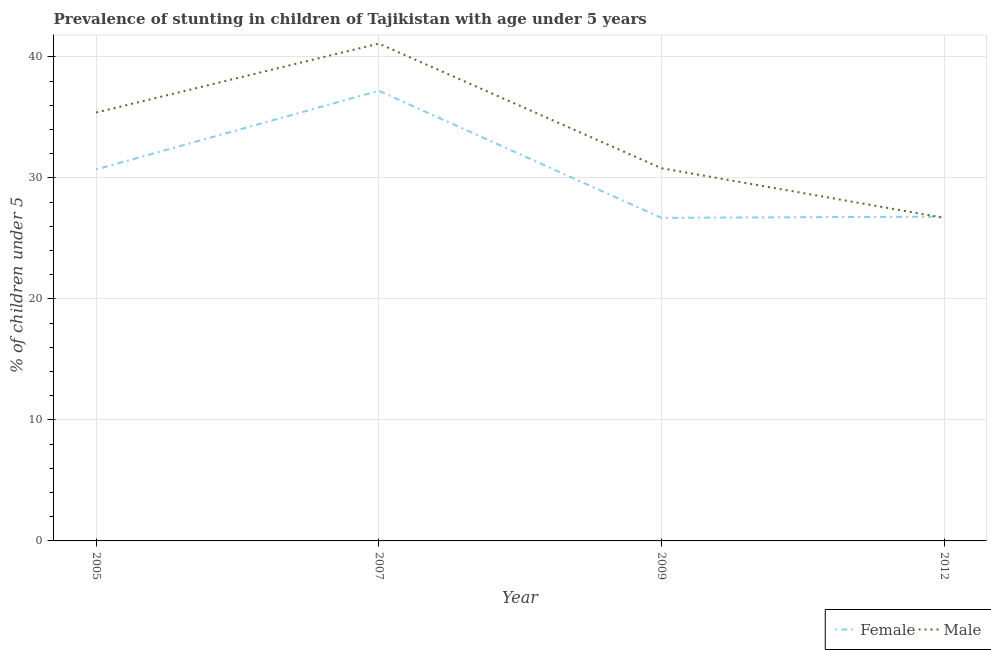How many different coloured lines are there?
Offer a very short reply. 2. Is the number of lines equal to the number of legend labels?
Offer a terse response. Yes. What is the percentage of stunted female children in 2012?
Provide a succinct answer. 26.8. Across all years, what is the maximum percentage of stunted male children?
Ensure brevity in your answer.  41.1. Across all years, what is the minimum percentage of stunted female children?
Provide a succinct answer. 26.7. In which year was the percentage of stunted female children maximum?
Provide a short and direct response. 2007. In which year was the percentage of stunted male children minimum?
Your response must be concise. 2012. What is the total percentage of stunted male children in the graph?
Give a very brief answer. 134. What is the difference between the percentage of stunted male children in 2005 and that in 2007?
Offer a very short reply. -5.7. What is the difference between the percentage of stunted female children in 2009 and the percentage of stunted male children in 2007?
Give a very brief answer. -14.4. What is the average percentage of stunted male children per year?
Make the answer very short. 33.5. In the year 2005, what is the difference between the percentage of stunted male children and percentage of stunted female children?
Provide a short and direct response. 4.7. In how many years, is the percentage of stunted female children greater than 30 %?
Offer a very short reply. 2. What is the ratio of the percentage of stunted female children in 2007 to that in 2012?
Give a very brief answer. 1.39. Is the percentage of stunted male children in 2005 less than that in 2012?
Provide a short and direct response. No. Is the difference between the percentage of stunted male children in 2007 and 2012 greater than the difference between the percentage of stunted female children in 2007 and 2012?
Keep it short and to the point. Yes. What is the difference between the highest and the second highest percentage of stunted female children?
Provide a succinct answer. 6.5. What is the difference between the highest and the lowest percentage of stunted female children?
Your response must be concise. 10.5. In how many years, is the percentage of stunted male children greater than the average percentage of stunted male children taken over all years?
Offer a terse response. 2. Is the sum of the percentage of stunted female children in 2005 and 2007 greater than the maximum percentage of stunted male children across all years?
Give a very brief answer. Yes. Is the percentage of stunted male children strictly greater than the percentage of stunted female children over the years?
Give a very brief answer. No. Does the graph contain grids?
Your response must be concise. Yes. How many legend labels are there?
Your response must be concise. 2. How are the legend labels stacked?
Your answer should be compact. Horizontal. What is the title of the graph?
Your response must be concise. Prevalence of stunting in children of Tajikistan with age under 5 years. What is the label or title of the Y-axis?
Keep it short and to the point.  % of children under 5. What is the  % of children under 5 in Female in 2005?
Give a very brief answer. 30.7. What is the  % of children under 5 of Male in 2005?
Your response must be concise. 35.4. What is the  % of children under 5 of Female in 2007?
Give a very brief answer. 37.2. What is the  % of children under 5 of Male in 2007?
Provide a short and direct response. 41.1. What is the  % of children under 5 of Female in 2009?
Your answer should be compact. 26.7. What is the  % of children under 5 of Male in 2009?
Keep it short and to the point. 30.8. What is the  % of children under 5 of Female in 2012?
Your answer should be compact. 26.8. What is the  % of children under 5 of Male in 2012?
Offer a terse response. 26.7. Across all years, what is the maximum  % of children under 5 of Female?
Offer a very short reply. 37.2. Across all years, what is the maximum  % of children under 5 of Male?
Offer a very short reply. 41.1. Across all years, what is the minimum  % of children under 5 of Female?
Give a very brief answer. 26.7. Across all years, what is the minimum  % of children under 5 of Male?
Provide a succinct answer. 26.7. What is the total  % of children under 5 in Female in the graph?
Your answer should be compact. 121.4. What is the total  % of children under 5 of Male in the graph?
Make the answer very short. 134. What is the difference between the  % of children under 5 in Female in 2005 and that in 2009?
Your answer should be compact. 4. What is the difference between the  % of children under 5 in Male in 2005 and that in 2009?
Your answer should be very brief. 4.6. What is the difference between the  % of children under 5 in Male in 2005 and that in 2012?
Make the answer very short. 8.7. What is the difference between the  % of children under 5 in Male in 2007 and that in 2009?
Your answer should be very brief. 10.3. What is the difference between the  % of children under 5 in Female in 2007 and that in 2012?
Make the answer very short. 10.4. What is the difference between the  % of children under 5 of Male in 2007 and that in 2012?
Make the answer very short. 14.4. What is the difference between the  % of children under 5 of Female in 2005 and the  % of children under 5 of Male in 2012?
Keep it short and to the point. 4. What is the difference between the  % of children under 5 in Female in 2007 and the  % of children under 5 in Male in 2012?
Provide a succinct answer. 10.5. What is the difference between the  % of children under 5 in Female in 2009 and the  % of children under 5 in Male in 2012?
Offer a terse response. 0. What is the average  % of children under 5 in Female per year?
Keep it short and to the point. 30.35. What is the average  % of children under 5 of Male per year?
Make the answer very short. 33.5. In the year 2005, what is the difference between the  % of children under 5 of Female and  % of children under 5 of Male?
Your response must be concise. -4.7. In the year 2009, what is the difference between the  % of children under 5 of Female and  % of children under 5 of Male?
Provide a succinct answer. -4.1. In the year 2012, what is the difference between the  % of children under 5 of Female and  % of children under 5 of Male?
Your answer should be compact. 0.1. What is the ratio of the  % of children under 5 of Female in 2005 to that in 2007?
Make the answer very short. 0.83. What is the ratio of the  % of children under 5 of Male in 2005 to that in 2007?
Keep it short and to the point. 0.86. What is the ratio of the  % of children under 5 in Female in 2005 to that in 2009?
Your response must be concise. 1.15. What is the ratio of the  % of children under 5 of Male in 2005 to that in 2009?
Ensure brevity in your answer.  1.15. What is the ratio of the  % of children under 5 in Female in 2005 to that in 2012?
Your answer should be compact. 1.15. What is the ratio of the  % of children under 5 in Male in 2005 to that in 2012?
Keep it short and to the point. 1.33. What is the ratio of the  % of children under 5 in Female in 2007 to that in 2009?
Make the answer very short. 1.39. What is the ratio of the  % of children under 5 of Male in 2007 to that in 2009?
Offer a terse response. 1.33. What is the ratio of the  % of children under 5 of Female in 2007 to that in 2012?
Your answer should be compact. 1.39. What is the ratio of the  % of children under 5 in Male in 2007 to that in 2012?
Provide a short and direct response. 1.54. What is the ratio of the  % of children under 5 of Female in 2009 to that in 2012?
Make the answer very short. 1. What is the ratio of the  % of children under 5 in Male in 2009 to that in 2012?
Your response must be concise. 1.15. What is the difference between the highest and the lowest  % of children under 5 of Female?
Keep it short and to the point. 10.5. 